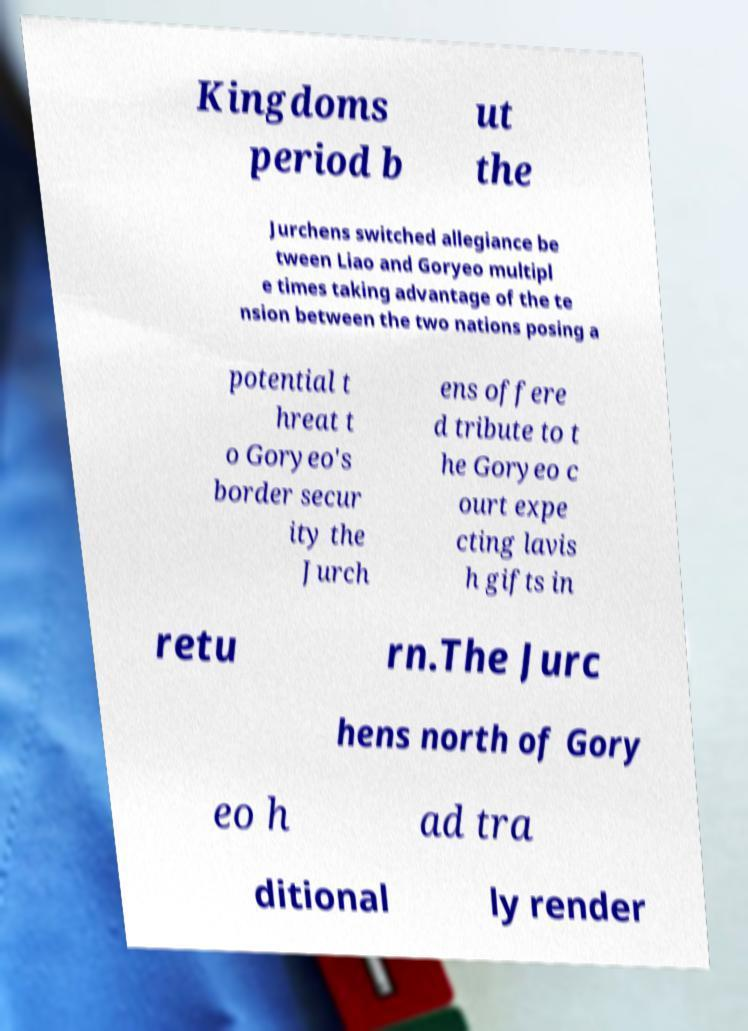Please identify and transcribe the text found in this image. Kingdoms period b ut the Jurchens switched allegiance be tween Liao and Goryeo multipl e times taking advantage of the te nsion between the two nations posing a potential t hreat t o Goryeo's border secur ity the Jurch ens offere d tribute to t he Goryeo c ourt expe cting lavis h gifts in retu rn.The Jurc hens north of Gory eo h ad tra ditional ly render 